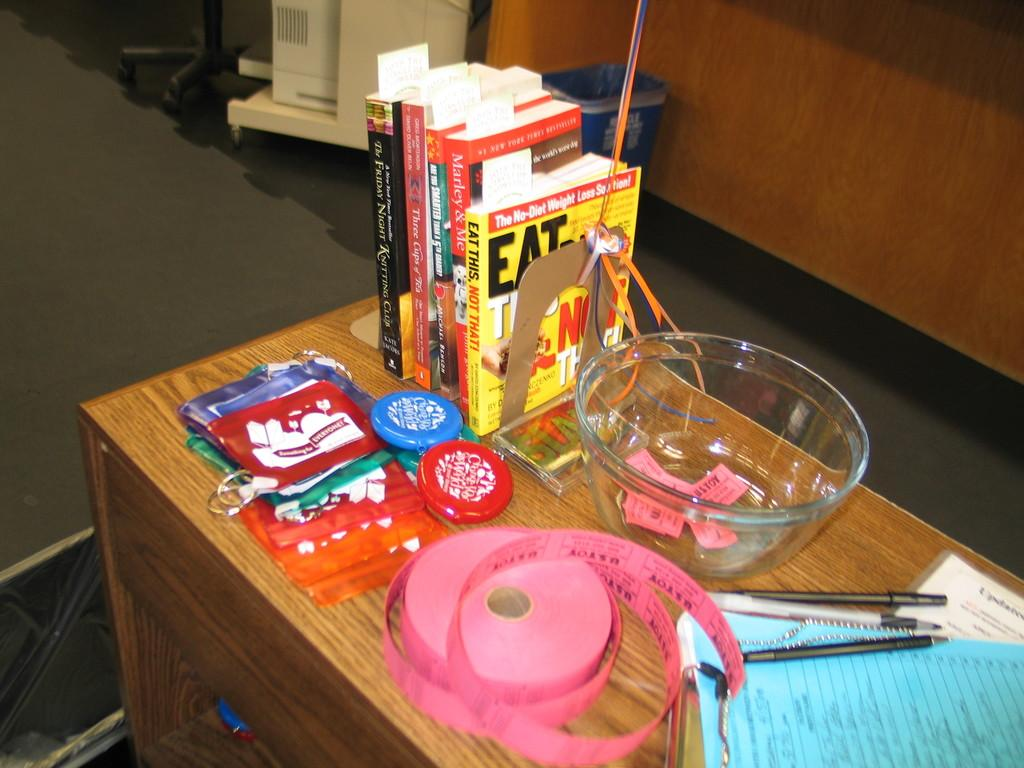<image>
Summarize the visual content of the image. a counter with tickets, coin holders, and books, one is entitled Eat This Not That. 